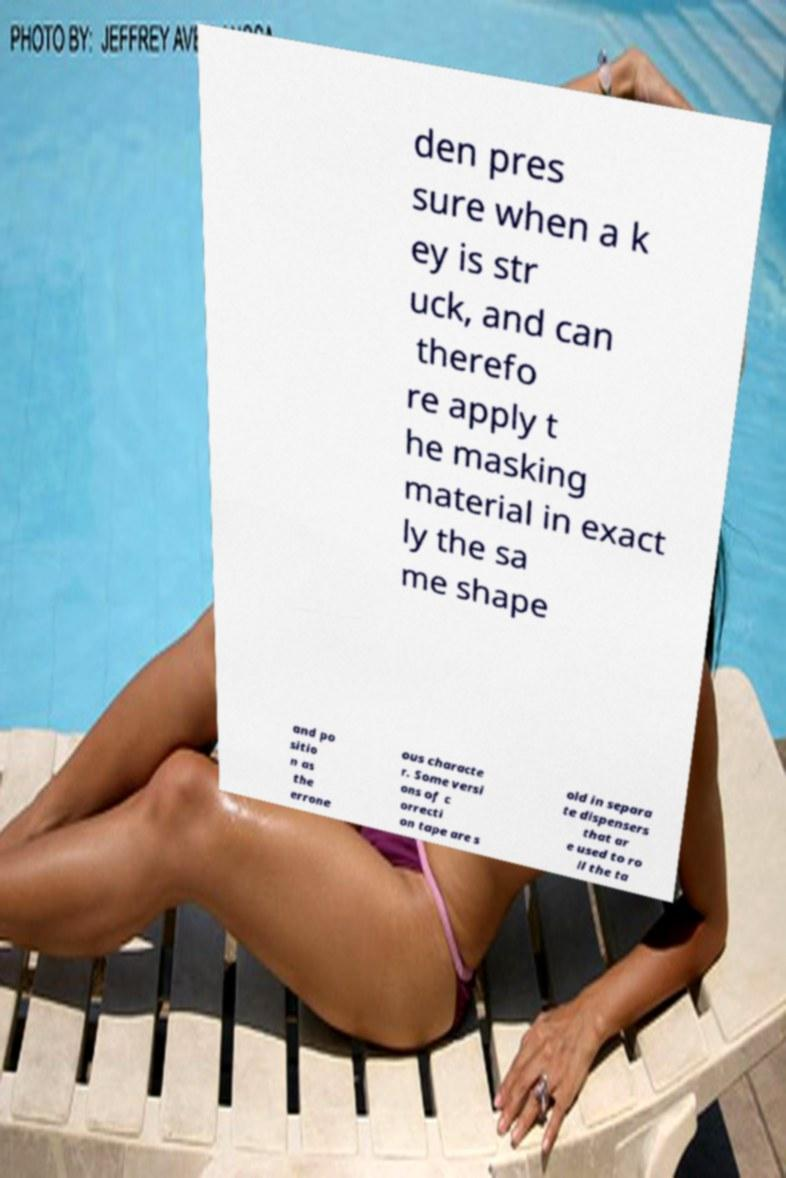What messages or text are displayed in this image? I need them in a readable, typed format. den pres sure when a k ey is str uck, and can therefo re apply t he masking material in exact ly the sa me shape and po sitio n as the errone ous characte r. Some versi ons of c orrecti on tape are s old in separa te dispensers that ar e used to ro ll the ta 